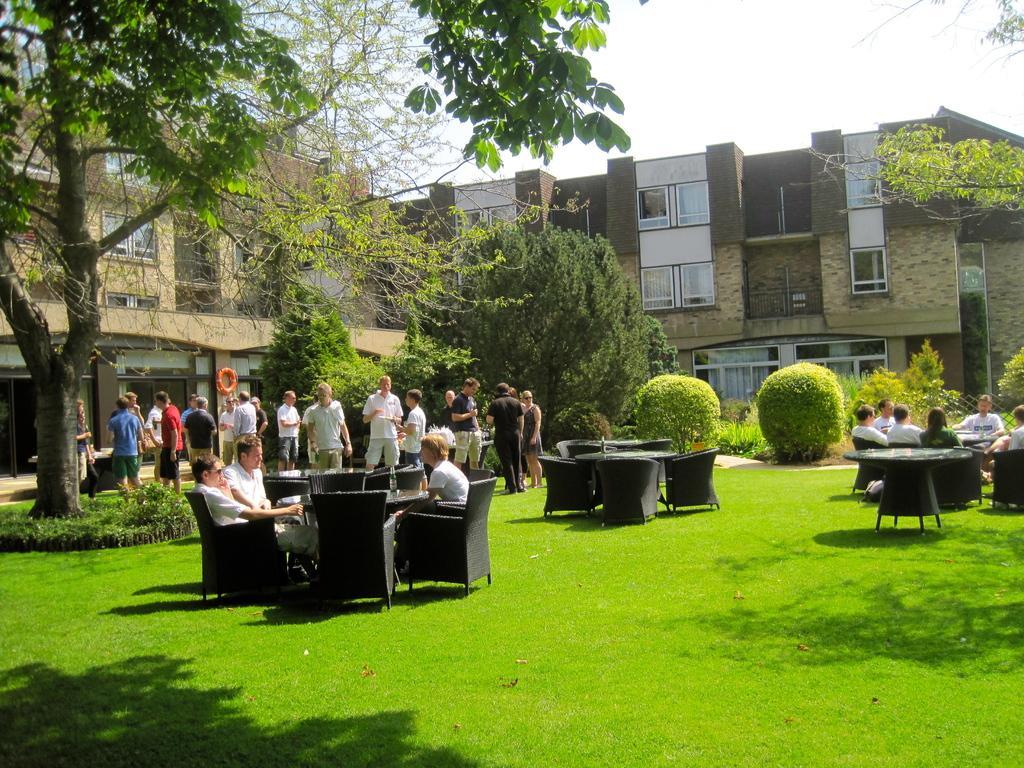Can you describe this image briefly? In the picture we can see a grass surface with some chairs and tables and some people are sitting on it and behind them, we can see some people are standing near the tree and in the background, we can see plants, trees and buildings with windows and behind it we can see the sky. 